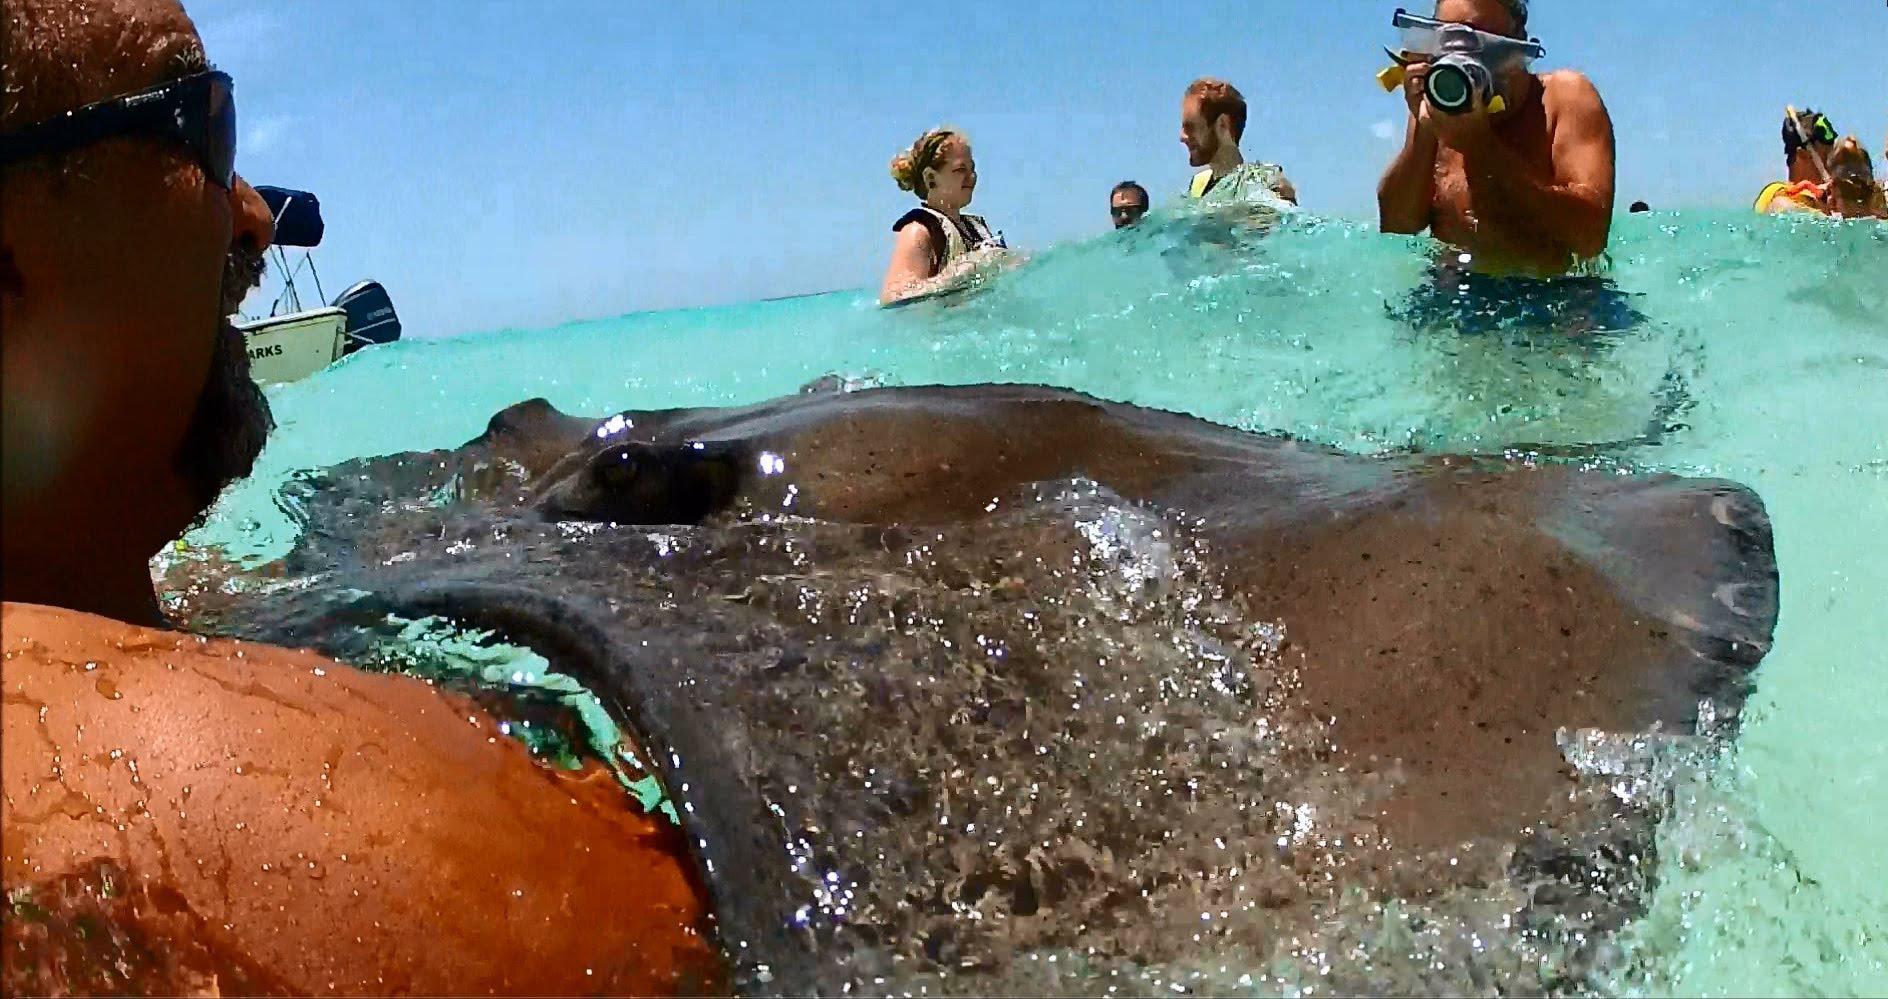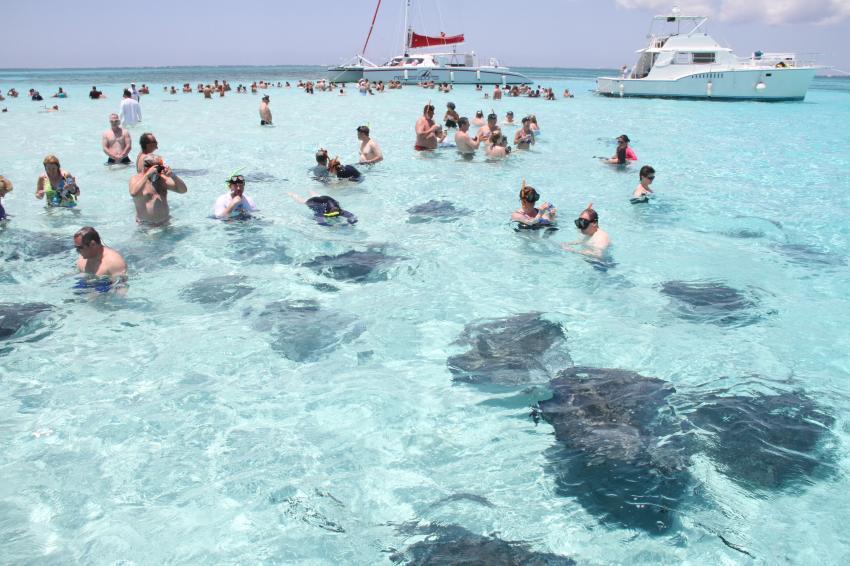The first image is the image on the left, the second image is the image on the right. For the images displayed, is the sentence "A female in the image on the left is standing in the water with a ray." factually correct? Answer yes or no. No. The first image is the image on the left, the second image is the image on the right. Given the left and right images, does the statement "Left image shows one brown-haired girl interacting with a large light gray stingray." hold true? Answer yes or no. No. 